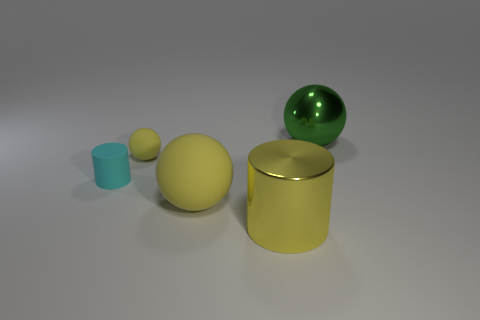Add 2 large spheres. How many objects exist? 7 Subtract all tiny spheres. How many spheres are left? 2 Add 5 large green metallic balls. How many large green metallic balls are left? 6 Add 3 small green cylinders. How many small green cylinders exist? 3 Subtract all green balls. How many balls are left? 2 Subtract 0 cyan cubes. How many objects are left? 5 Subtract all cylinders. How many objects are left? 3 Subtract 1 spheres. How many spheres are left? 2 Subtract all brown balls. Subtract all purple blocks. How many balls are left? 3 Subtract all green cylinders. How many brown spheres are left? 0 